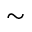<formula> <loc_0><loc_0><loc_500><loc_500>\sim</formula> 